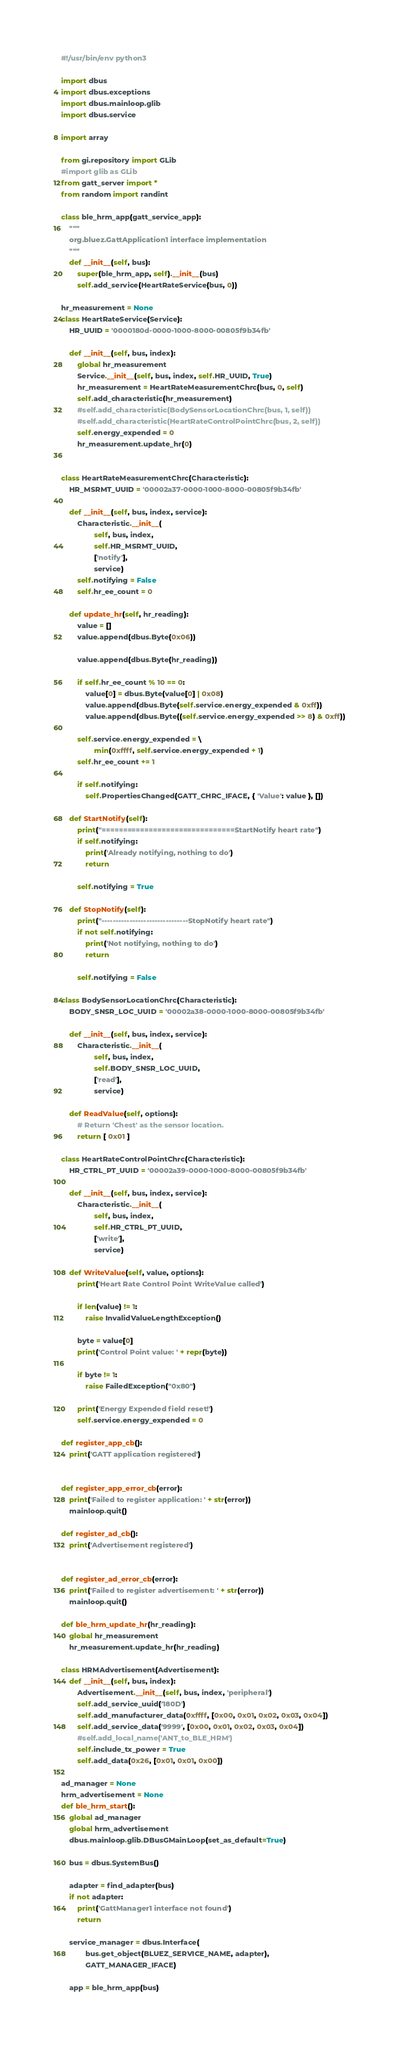Convert code to text. <code><loc_0><loc_0><loc_500><loc_500><_Python_>#!/usr/bin/env python3

import dbus
import dbus.exceptions
import dbus.mainloop.glib
import dbus.service

import array

from gi.repository import GLib
#import glib as GLib
from gatt_server import *
from random import randint

class ble_hrm_app(gatt_service_app):
    """
    org.bluez.GattApplication1 interface implementation
    """
    def __init__(self, bus):
        super(ble_hrm_app, self).__init__(bus)
        self.add_service(HeartRateService(bus, 0))

hr_measurement = None
class HeartRateService(Service):
    HR_UUID = '0000180d-0000-1000-8000-00805f9b34fb'

    def __init__(self, bus, index):
        global hr_measurement
        Service.__init__(self, bus, index, self.HR_UUID, True)
        hr_measurement = HeartRateMeasurementChrc(bus, 0, self)
        self.add_characteristic(hr_measurement)
        #self.add_characteristic(BodySensorLocationChrc(bus, 1, self))
        #self.add_characteristic(HeartRateControlPointChrc(bus, 2, self))
        self.energy_expended = 0
        hr_measurement.update_hr(0)


class HeartRateMeasurementChrc(Characteristic):
    HR_MSRMT_UUID = '00002a37-0000-1000-8000-00805f9b34fb'

    def __init__(self, bus, index, service):
        Characteristic.__init__(
                self, bus, index,
                self.HR_MSRMT_UUID,
                ['notify'],
                service)
        self.notifying = False
        self.hr_ee_count = 0

    def update_hr(self, hr_reading):
        value = []
        value.append(dbus.Byte(0x06))

        value.append(dbus.Byte(hr_reading))

        if self.hr_ee_count % 10 == 0:
            value[0] = dbus.Byte(value[0] | 0x08)
            value.append(dbus.Byte(self.service.energy_expended & 0xff))
            value.append(dbus.Byte((self.service.energy_expended >> 8) & 0xff))

        self.service.energy_expended = \
                min(0xffff, self.service.energy_expended + 1)
        self.hr_ee_count += 1

        if self.notifying:
            self.PropertiesChanged(GATT_CHRC_IFACE, { 'Value': value }, [])

    def StartNotify(self):
        print("===============================StartNotify heart rate")
        if self.notifying:
            print('Already notifying, nothing to do')
            return

        self.notifying = True

    def StopNotify(self):
        print("-------------------------------StopNotify heart rate")
        if not self.notifying:
            print('Not notifying, nothing to do')
            return

        self.notifying = False

class BodySensorLocationChrc(Characteristic):
    BODY_SNSR_LOC_UUID = '00002a38-0000-1000-8000-00805f9b34fb'

    def __init__(self, bus, index, service):
        Characteristic.__init__(
                self, bus, index,
                self.BODY_SNSR_LOC_UUID,
                ['read'],
                service)

    def ReadValue(self, options):
        # Return 'Chest' as the sensor location.
        return [ 0x01 ]

class HeartRateControlPointChrc(Characteristic):
    HR_CTRL_PT_UUID = '00002a39-0000-1000-8000-00805f9b34fb'

    def __init__(self, bus, index, service):
        Characteristic.__init__(
                self, bus, index,
                self.HR_CTRL_PT_UUID,
                ['write'],
                service)

    def WriteValue(self, value, options):
        print('Heart Rate Control Point WriteValue called')

        if len(value) != 1:
            raise InvalidValueLengthException()

        byte = value[0]
        print('Control Point value: ' + repr(byte))

        if byte != 1:
            raise FailedException("0x80")

        print('Energy Expended field reset!')
        self.service.energy_expended = 0

def register_app_cb():
    print('GATT application registered')


def register_app_error_cb(error):
    print('Failed to register application: ' + str(error))
    mainloop.quit()

def register_ad_cb():
    print('Advertisement registered')


def register_ad_error_cb(error):
    print('Failed to register advertisement: ' + str(error))
    mainloop.quit()

def ble_hrm_update_hr(hr_reading):
    global hr_measurement
    hr_measurement.update_hr(hr_reading)

class HRMAdvertisement(Advertisement):
    def __init__(self, bus, index):
        Advertisement.__init__(self, bus, index, 'peripheral')
        self.add_service_uuid('180D')
        self.add_manufacturer_data(0xffff, [0x00, 0x01, 0x02, 0x03, 0x04])
        self.add_service_data('9999', [0x00, 0x01, 0x02, 0x03, 0x04])
        #self.add_local_name('ANT_to_BLE_HRM')
        self.include_tx_power = True
        self.add_data(0x26, [0x01, 0x01, 0x00])

ad_manager = None
hrm_advertisement = None
def ble_hrm_start():
    global ad_manager
    global hrm_advertisement
    dbus.mainloop.glib.DBusGMainLoop(set_as_default=True)

    bus = dbus.SystemBus()

    adapter = find_adapter(bus)
    if not adapter:
        print('GattManager1 interface not found')
        return

    service_manager = dbus.Interface(
            bus.get_object(BLUEZ_SERVICE_NAME, adapter),
            GATT_MANAGER_IFACE)

    app = ble_hrm_app(bus)
</code> 